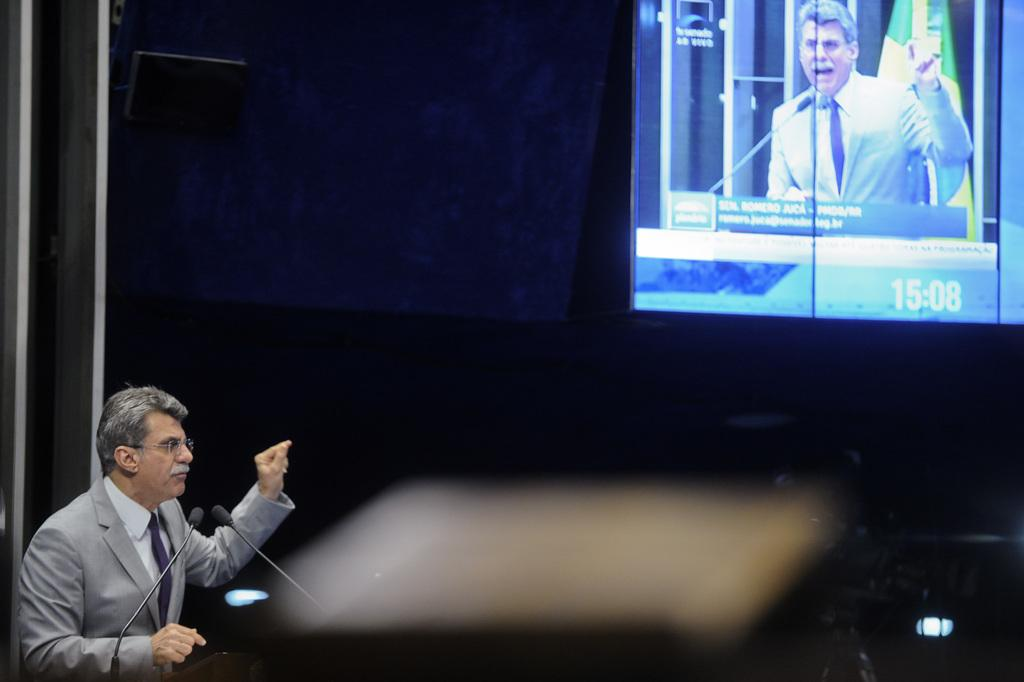<image>
Give a short and clear explanation of the subsequent image. A man is giving a speech and pointing toward a screen which shows the time 15:08. 